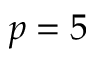<formula> <loc_0><loc_0><loc_500><loc_500>p = 5</formula> 